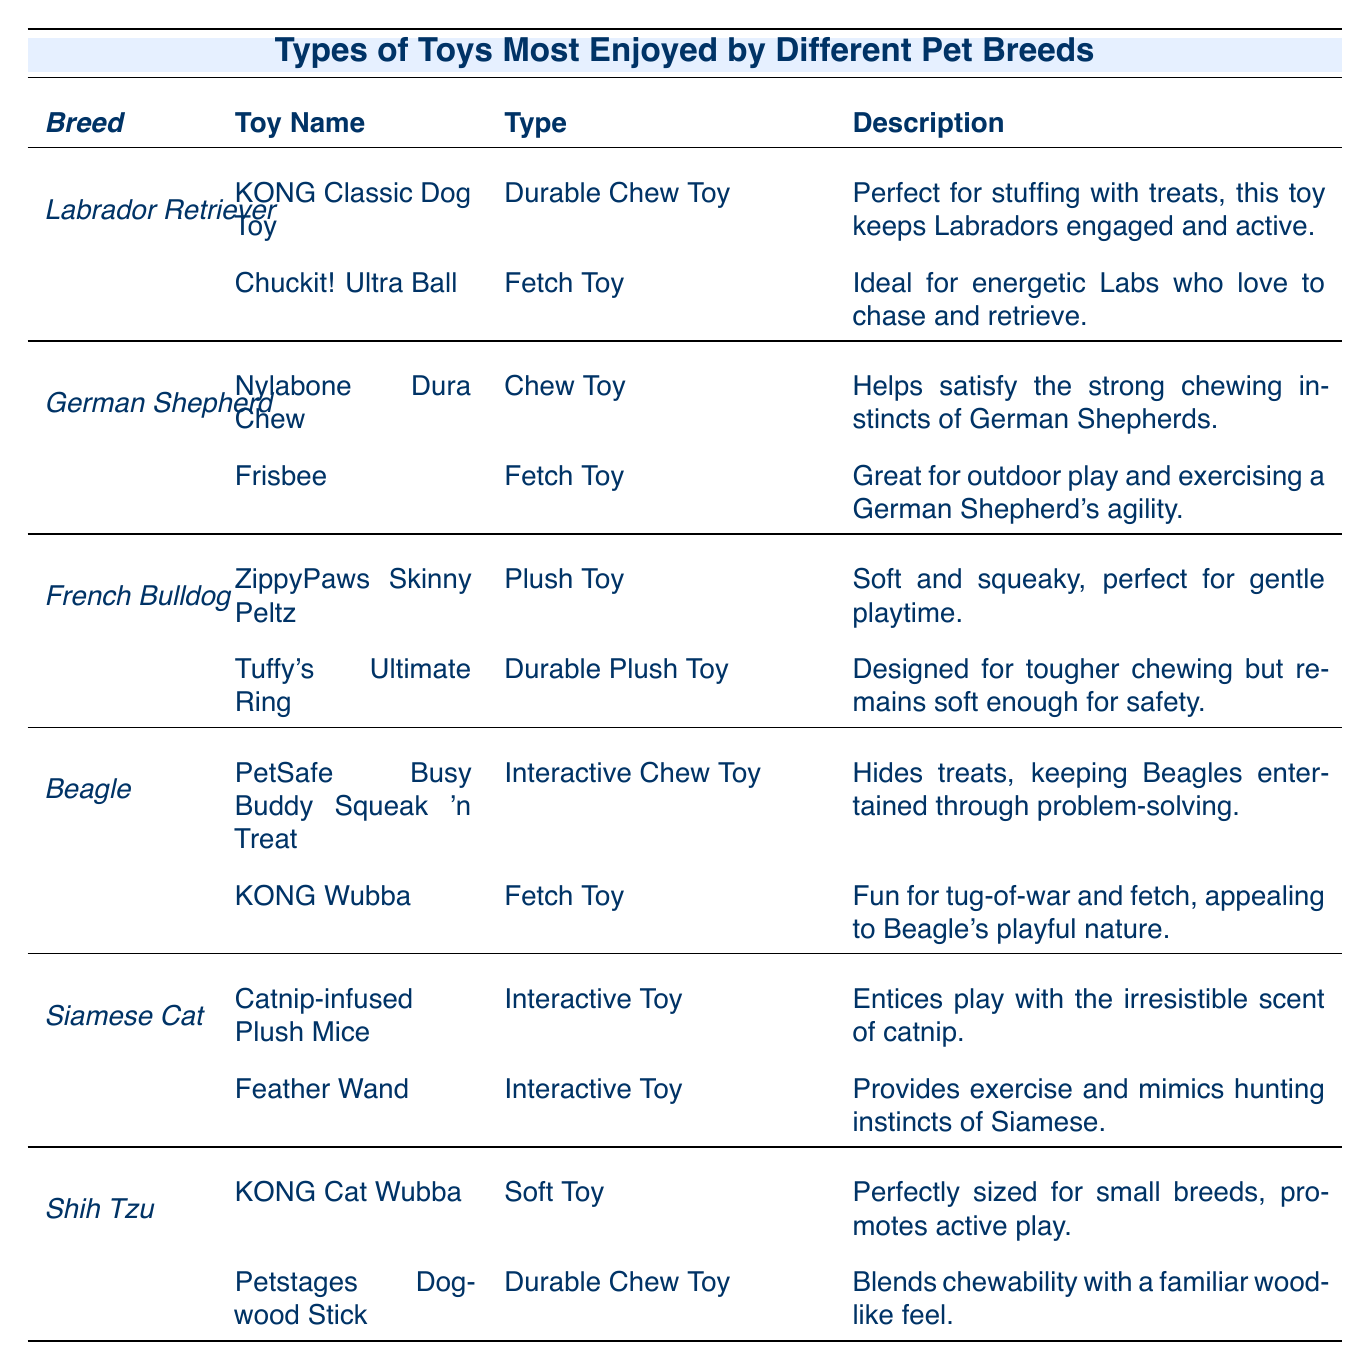What toys do Labrador Retrievers prefer? According to the table, Labrador Retrievers prefer the KONG Classic Dog Toy and the Chuckit! Ultra Ball.
Answer: KONG Classic Dog Toy, Chuckit! Ultra Ball Which breed prefers the Nylabone Dura Chew toy? The table indicates that the Nylabone Dura Chew toy is preferred by the German Shepherd breed.
Answer: German Shepherd How many types of toys do Beagles enjoy? In the table, Beagles enjoy two types of toys: PetSafe Busy Buddy Squeak 'n Treat (Interactive Chew Toy) and KONG Wubba (Fetch Toy).
Answer: 2 Is the KONG Cat Wubba a fetch toy? The table lists the KONG Cat Wubba as a Soft Toy, not a fetch toy.
Answer: No Which breed has a preference for durable chew toys? Both Labrador Retrievers and Shih Tzus prefer durable chew toys, specifically the KONG Classic Dog Toy and Petstages Dogwood Stick.
Answer: Labrador Retriever, Shih Tzu What is the primary activity associated with the Frisbee toy for German Shepherds? The table states that the Frisbee is great for outdoor play and helps exercise a German Shepherd's agility.
Answer: Outdoor play, agility exercise Which pet breed enjoys toys that help with problem-solving? The Beagle breed enjoys toys that help with problem-solving, particularly the PetSafe Busy Buddy Squeak 'n Treat.
Answer: Beagle Are interactive toys preferred by Siamese Cats? Yes, both of the toys preferred by Siamese Cats, Catnip-infused Plush Mice and Feather Wand, are classified as Interactive Toys.
Answer: Yes What type of toy is favored by French Bulldogs? French Bulldogs prefer plush toys, specifically the ZippyPaws Skinny Peltz and Tuffy's Ultimate Ring.
Answer: Plush toys Which breed has toys that are perfect for gentle playtime? The French Bulldog has toys like ZippyPaws Skinny Peltz that are perfect for gentle playtime.
Answer: French Bulldog How many breeds prefer fetch toys, and which are they? In total, three breeds prefer fetch toys: Labrador Retriever (Chuckit! Ultra Ball), German Shepherd (Frisbee), and Beagle (KONG Wubba).
Answer: 3 breeds: Labrador Retriever, German Shepherd, Beagle What is the function of the toy named "KONG Wubba"? The KONG Wubba is fun for tug-of-war and fetch, appealing to a Beagle's playful nature, according to the description.
Answer: Tug-of-war and fetch Does the description for the Tuffy's Ultimate Ring indicate it is soft for safety? Yes, the description states it is designed for tougher chewing but remains soft enough for safety.
Answer: Yes Which breed has toys that mimic hunting instincts? The Siamese Cat has toys like the Feather Wand that provide exercise and mimic hunting instincts.
Answer: Siamese Cat What are the two toy types most associated with Labrador Retrievers? The two types of toys most associated with Labrador Retrievers are Durable Chew Toys and Fetch Toys.
Answer: Durable Chew Toy, Fetch Toy 